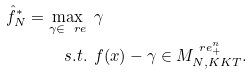Convert formula to latex. <formula><loc_0><loc_0><loc_500><loc_500>\hat { f } ^ { * } _ { N } = \max _ { \gamma \in \ r e } & \, \ \gamma \\ s . t . & \, \ f ( x ) - \gamma \in M _ { N , K K T } ^ { \ r e ^ { n } _ { + } } .</formula> 